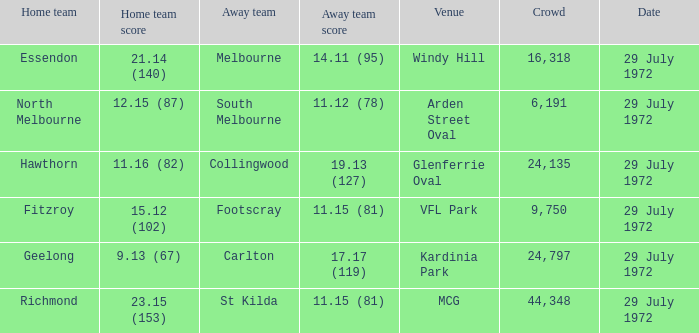When collingwood was the away team, what was the home team? Hawthorn. 